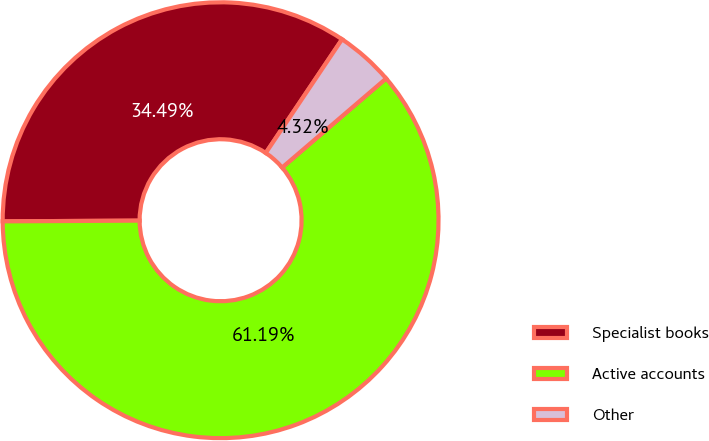Convert chart to OTSL. <chart><loc_0><loc_0><loc_500><loc_500><pie_chart><fcel>Specialist books<fcel>Active accounts<fcel>Other<nl><fcel>34.49%<fcel>61.19%<fcel>4.32%<nl></chart> 